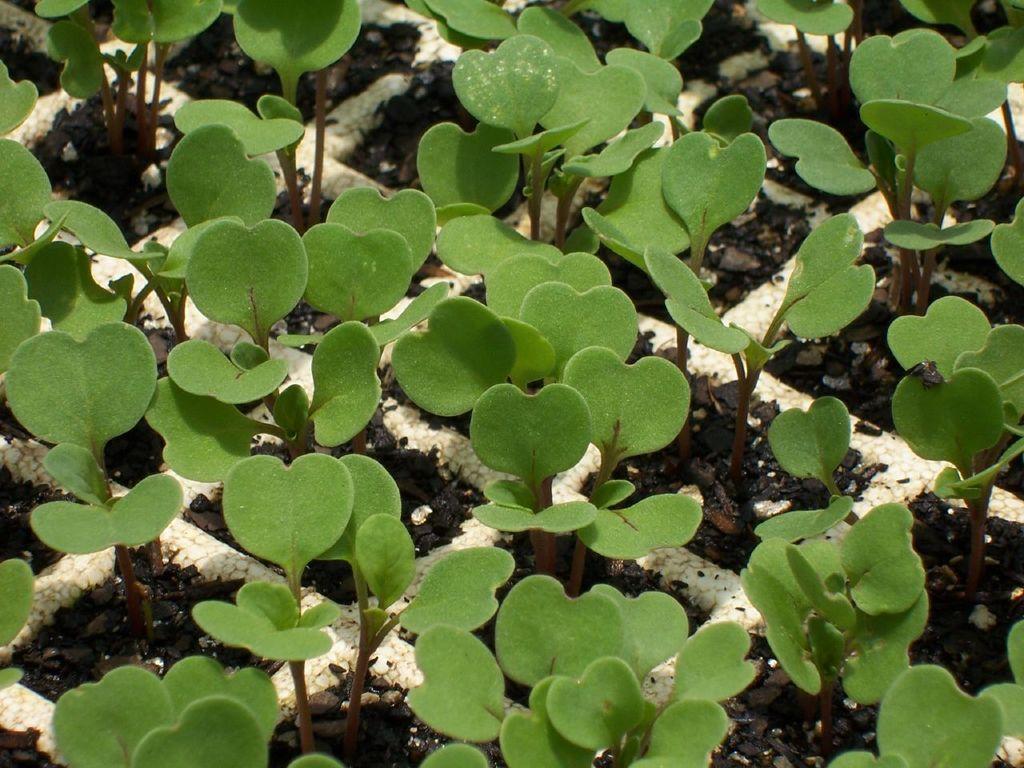Describe this image in one or two sentences. In the image there is a planting grid with soil and plants. 